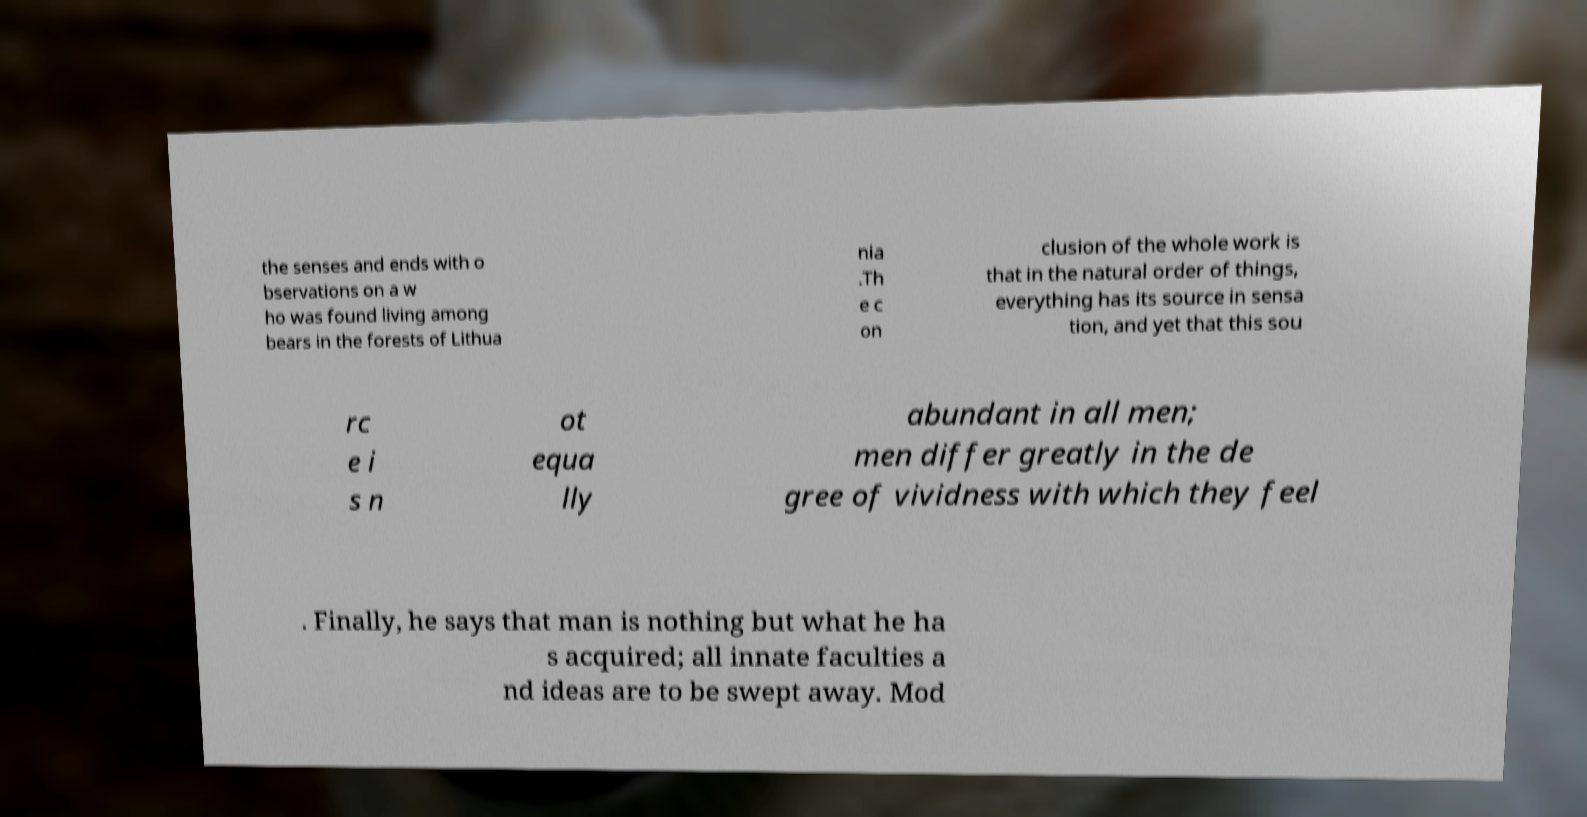What messages or text are displayed in this image? I need them in a readable, typed format. the senses and ends with o bservations on a w ho was found living among bears in the forests of Lithua nia .Th e c on clusion of the whole work is that in the natural order of things, everything has its source in sensa tion, and yet that this sou rc e i s n ot equa lly abundant in all men; men differ greatly in the de gree of vividness with which they feel . Finally, he says that man is nothing but what he ha s acquired; all innate faculties a nd ideas are to be swept away. Mod 